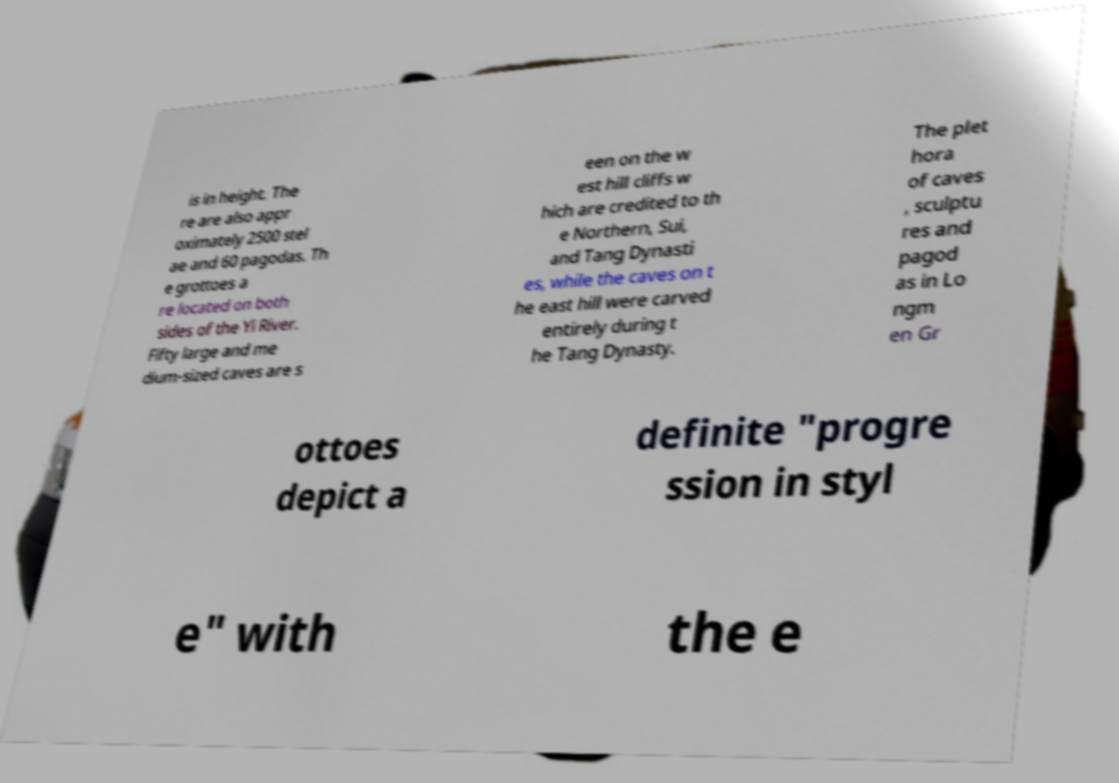I need the written content from this picture converted into text. Can you do that? is in height. The re are also appr oximately 2500 stel ae and 60 pagodas. Th e grottoes a re located on both sides of the Yi River. Fifty large and me dium-sized caves are s een on the w est hill cliffs w hich are credited to th e Northern, Sui, and Tang Dynasti es, while the caves on t he east hill were carved entirely during t he Tang Dynasty. The plet hora of caves , sculptu res and pagod as in Lo ngm en Gr ottoes depict a definite "progre ssion in styl e" with the e 